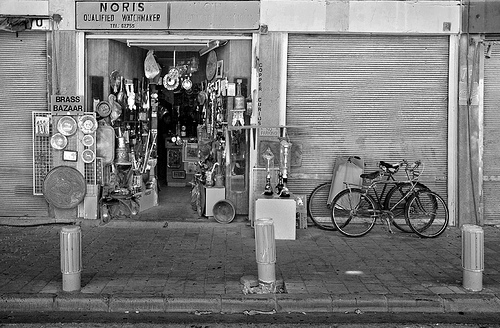What kind of items are being sold at the store? The store appears to specialize in brass items and perhaps other antiques. There are various brass plates, vases, and decorative articles displayed prominently. Is this store still in business? Based on the image, the store appears to be open as the displays are out front, suggesting it is operational during the time the photo was taken. 